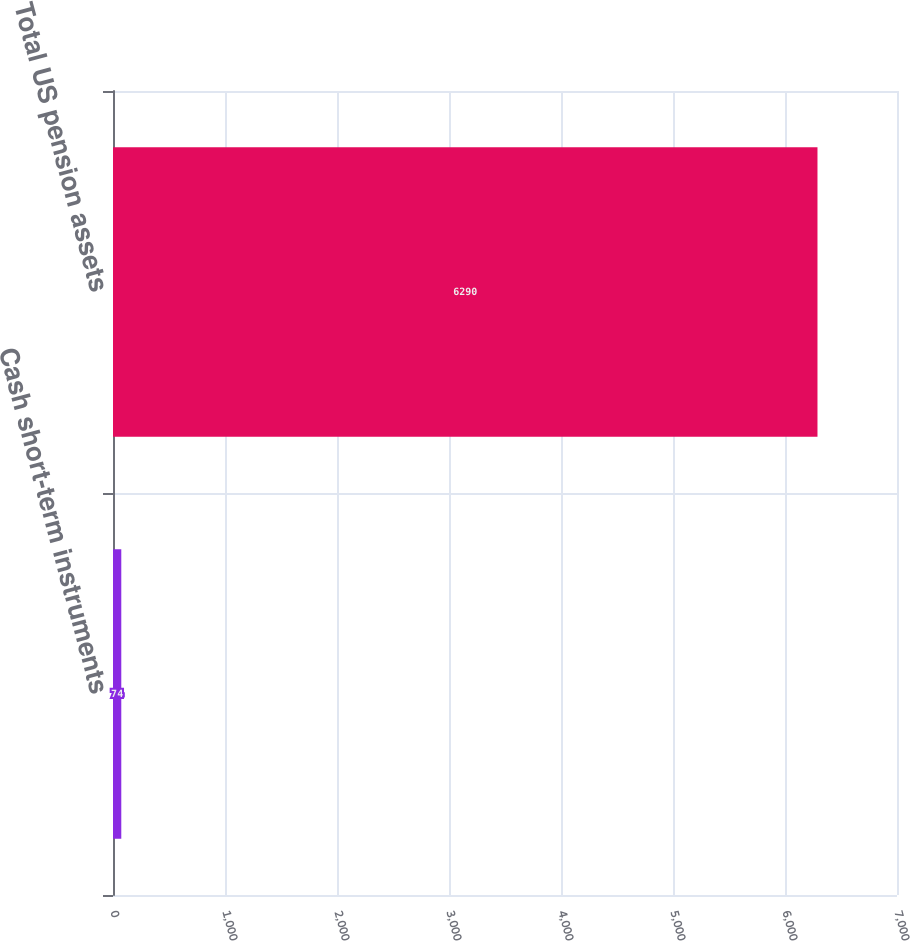Convert chart to OTSL. <chart><loc_0><loc_0><loc_500><loc_500><bar_chart><fcel>Cash short-term instruments<fcel>Total US pension assets<nl><fcel>74<fcel>6290<nl></chart> 